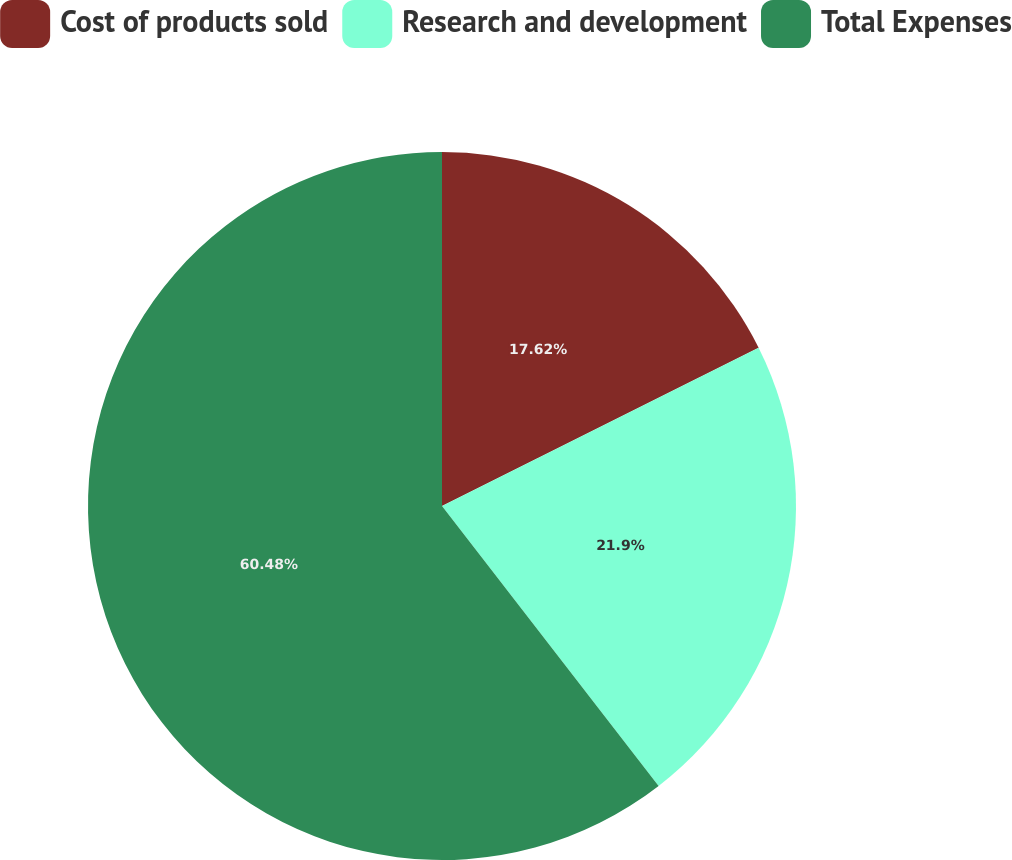<chart> <loc_0><loc_0><loc_500><loc_500><pie_chart><fcel>Cost of products sold<fcel>Research and development<fcel>Total Expenses<nl><fcel>17.62%<fcel>21.9%<fcel>60.48%<nl></chart> 